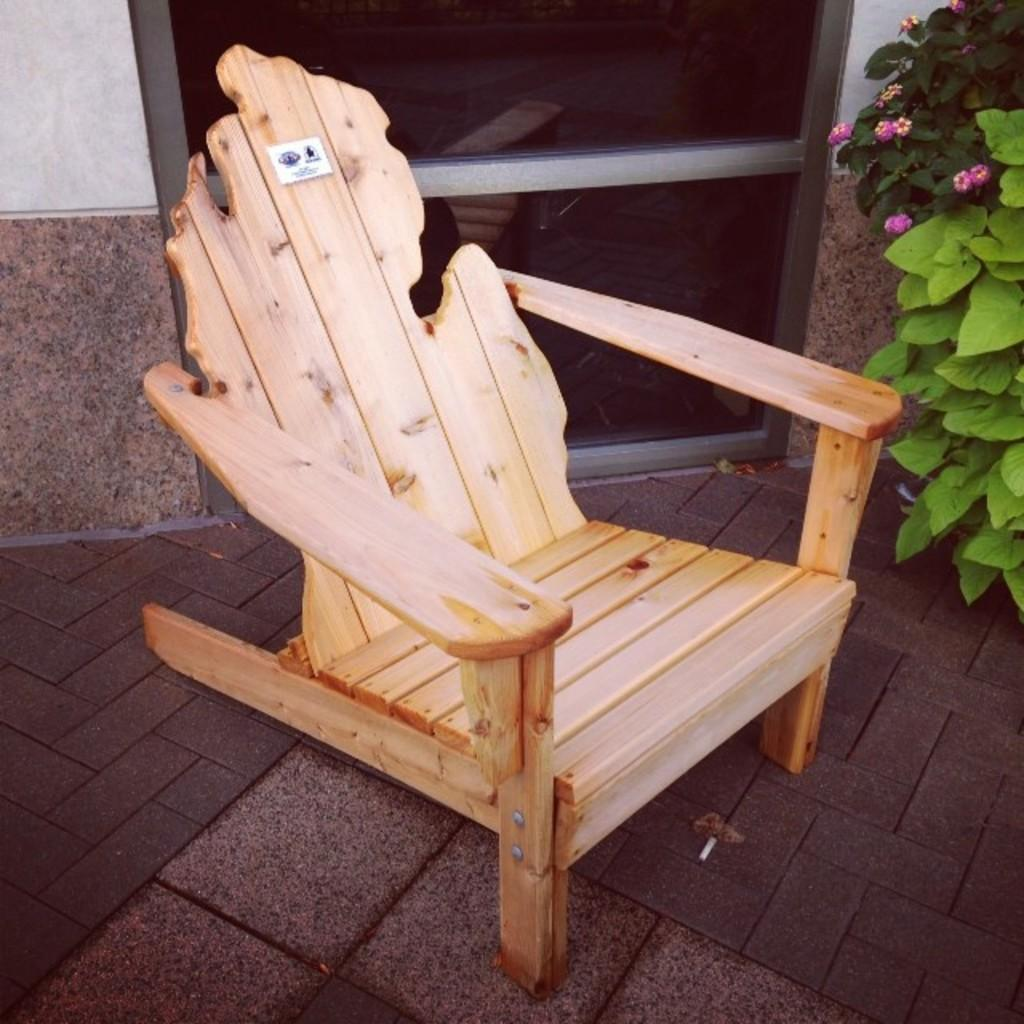What piece of furniture is on the floor in the image? There is a chair on the floor in the image. What architectural feature can be seen in the image? There is a door visible in the image. What type of structure is present in the image? There is a wall in the image. What type of plant is in the image? There is a plant in the image, and it has flowers associated with it. Can you describe the fog surrounding the chair in the image? There is no fog present in the image; it features a chair on the floor, a door, a wall, a plant with flowers, but no fog. What type of skate is visible on the wall in the image? There is no skate present in the image; it features a chair on the floor, a door, a wall, a plant with flowers, but no skate. 